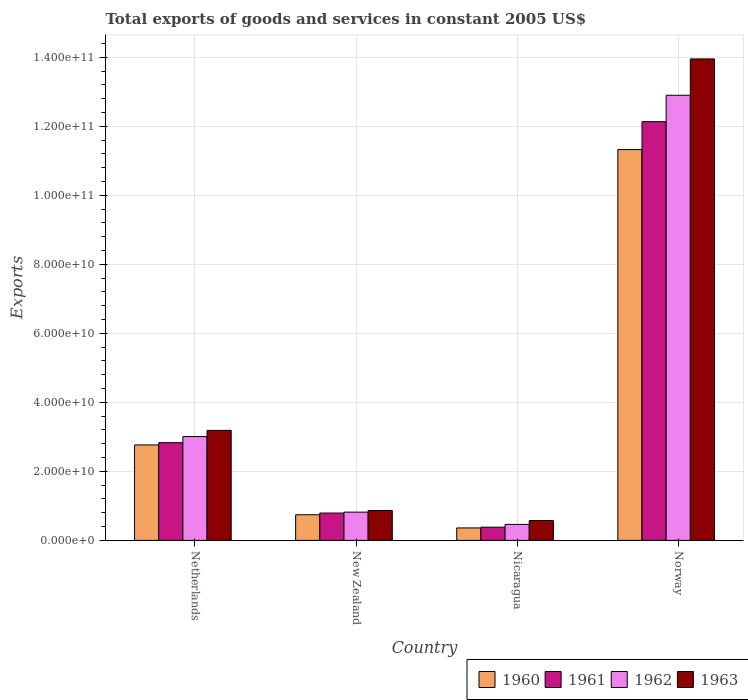How many different coloured bars are there?
Provide a succinct answer. 4. What is the label of the 2nd group of bars from the left?
Your answer should be very brief. New Zealand. In how many cases, is the number of bars for a given country not equal to the number of legend labels?
Ensure brevity in your answer.  0. What is the total exports of goods and services in 1961 in Netherlands?
Provide a succinct answer. 2.83e+1. Across all countries, what is the maximum total exports of goods and services in 1962?
Provide a succinct answer. 1.29e+11. Across all countries, what is the minimum total exports of goods and services in 1963?
Provide a short and direct response. 5.74e+09. In which country was the total exports of goods and services in 1961 minimum?
Offer a very short reply. Nicaragua. What is the total total exports of goods and services in 1961 in the graph?
Your answer should be very brief. 1.61e+11. What is the difference between the total exports of goods and services in 1962 in New Zealand and that in Nicaragua?
Give a very brief answer. 3.55e+09. What is the difference between the total exports of goods and services in 1961 in New Zealand and the total exports of goods and services in 1960 in Netherlands?
Your answer should be very brief. -1.97e+1. What is the average total exports of goods and services in 1963 per country?
Offer a terse response. 4.64e+1. What is the difference between the total exports of goods and services of/in 1960 and total exports of goods and services of/in 1961 in Nicaragua?
Give a very brief answer. -2.16e+08. What is the ratio of the total exports of goods and services in 1963 in Netherlands to that in Norway?
Your answer should be very brief. 0.23. Is the difference between the total exports of goods and services in 1960 in New Zealand and Nicaragua greater than the difference between the total exports of goods and services in 1961 in New Zealand and Nicaragua?
Ensure brevity in your answer.  No. What is the difference between the highest and the second highest total exports of goods and services in 1962?
Keep it short and to the point. 1.21e+11. What is the difference between the highest and the lowest total exports of goods and services in 1962?
Keep it short and to the point. 1.24e+11. Is it the case that in every country, the sum of the total exports of goods and services in 1962 and total exports of goods and services in 1960 is greater than the sum of total exports of goods and services in 1963 and total exports of goods and services in 1961?
Give a very brief answer. No. What does the 4th bar from the left in Nicaragua represents?
Offer a very short reply. 1963. How many countries are there in the graph?
Ensure brevity in your answer.  4. What is the difference between two consecutive major ticks on the Y-axis?
Offer a very short reply. 2.00e+1. Where does the legend appear in the graph?
Keep it short and to the point. Bottom right. How are the legend labels stacked?
Ensure brevity in your answer.  Horizontal. What is the title of the graph?
Your answer should be compact. Total exports of goods and services in constant 2005 US$. Does "1991" appear as one of the legend labels in the graph?
Make the answer very short. No. What is the label or title of the Y-axis?
Make the answer very short. Exports. What is the Exports of 1960 in Netherlands?
Provide a short and direct response. 2.77e+1. What is the Exports of 1961 in Netherlands?
Ensure brevity in your answer.  2.83e+1. What is the Exports of 1962 in Netherlands?
Provide a short and direct response. 3.01e+1. What is the Exports in 1963 in Netherlands?
Provide a succinct answer. 3.19e+1. What is the Exports in 1960 in New Zealand?
Ensure brevity in your answer.  7.43e+09. What is the Exports in 1961 in New Zealand?
Offer a very short reply. 7.92e+09. What is the Exports of 1962 in New Zealand?
Make the answer very short. 8.19e+09. What is the Exports of 1963 in New Zealand?
Your response must be concise. 8.66e+09. What is the Exports of 1960 in Nicaragua?
Provide a short and direct response. 3.61e+09. What is the Exports of 1961 in Nicaragua?
Ensure brevity in your answer.  3.83e+09. What is the Exports in 1962 in Nicaragua?
Keep it short and to the point. 4.64e+09. What is the Exports in 1963 in Nicaragua?
Your answer should be very brief. 5.74e+09. What is the Exports in 1960 in Norway?
Give a very brief answer. 1.13e+11. What is the Exports of 1961 in Norway?
Keep it short and to the point. 1.21e+11. What is the Exports in 1962 in Norway?
Your answer should be very brief. 1.29e+11. What is the Exports of 1963 in Norway?
Offer a terse response. 1.40e+11. Across all countries, what is the maximum Exports in 1960?
Offer a terse response. 1.13e+11. Across all countries, what is the maximum Exports of 1961?
Your answer should be compact. 1.21e+11. Across all countries, what is the maximum Exports of 1962?
Your answer should be very brief. 1.29e+11. Across all countries, what is the maximum Exports in 1963?
Your answer should be very brief. 1.40e+11. Across all countries, what is the minimum Exports in 1960?
Offer a very short reply. 3.61e+09. Across all countries, what is the minimum Exports of 1961?
Ensure brevity in your answer.  3.83e+09. Across all countries, what is the minimum Exports in 1962?
Keep it short and to the point. 4.64e+09. Across all countries, what is the minimum Exports in 1963?
Offer a very short reply. 5.74e+09. What is the total Exports in 1960 in the graph?
Your answer should be very brief. 1.52e+11. What is the total Exports in 1961 in the graph?
Your response must be concise. 1.61e+11. What is the total Exports in 1962 in the graph?
Your response must be concise. 1.72e+11. What is the total Exports in 1963 in the graph?
Keep it short and to the point. 1.86e+11. What is the difference between the Exports of 1960 in Netherlands and that in New Zealand?
Your response must be concise. 2.02e+1. What is the difference between the Exports of 1961 in Netherlands and that in New Zealand?
Ensure brevity in your answer.  2.04e+1. What is the difference between the Exports of 1962 in Netherlands and that in New Zealand?
Your answer should be very brief. 2.19e+1. What is the difference between the Exports of 1963 in Netherlands and that in New Zealand?
Offer a very short reply. 2.32e+1. What is the difference between the Exports in 1960 in Netherlands and that in Nicaragua?
Provide a short and direct response. 2.41e+1. What is the difference between the Exports in 1961 in Netherlands and that in Nicaragua?
Provide a succinct answer. 2.45e+1. What is the difference between the Exports of 1962 in Netherlands and that in Nicaragua?
Your answer should be very brief. 2.54e+1. What is the difference between the Exports of 1963 in Netherlands and that in Nicaragua?
Keep it short and to the point. 2.61e+1. What is the difference between the Exports in 1960 in Netherlands and that in Norway?
Ensure brevity in your answer.  -8.56e+1. What is the difference between the Exports of 1961 in Netherlands and that in Norway?
Your answer should be very brief. -9.30e+1. What is the difference between the Exports of 1962 in Netherlands and that in Norway?
Make the answer very short. -9.89e+1. What is the difference between the Exports of 1963 in Netherlands and that in Norway?
Your response must be concise. -1.08e+11. What is the difference between the Exports of 1960 in New Zealand and that in Nicaragua?
Make the answer very short. 3.82e+09. What is the difference between the Exports of 1961 in New Zealand and that in Nicaragua?
Offer a very short reply. 4.10e+09. What is the difference between the Exports in 1962 in New Zealand and that in Nicaragua?
Offer a terse response. 3.55e+09. What is the difference between the Exports of 1963 in New Zealand and that in Nicaragua?
Keep it short and to the point. 2.92e+09. What is the difference between the Exports in 1960 in New Zealand and that in Norway?
Your answer should be compact. -1.06e+11. What is the difference between the Exports of 1961 in New Zealand and that in Norway?
Give a very brief answer. -1.13e+11. What is the difference between the Exports in 1962 in New Zealand and that in Norway?
Offer a terse response. -1.21e+11. What is the difference between the Exports in 1963 in New Zealand and that in Norway?
Give a very brief answer. -1.31e+11. What is the difference between the Exports of 1960 in Nicaragua and that in Norway?
Your response must be concise. -1.10e+11. What is the difference between the Exports in 1961 in Nicaragua and that in Norway?
Keep it short and to the point. -1.18e+11. What is the difference between the Exports of 1962 in Nicaragua and that in Norway?
Offer a very short reply. -1.24e+11. What is the difference between the Exports in 1963 in Nicaragua and that in Norway?
Keep it short and to the point. -1.34e+11. What is the difference between the Exports in 1960 in Netherlands and the Exports in 1961 in New Zealand?
Give a very brief answer. 1.97e+1. What is the difference between the Exports of 1960 in Netherlands and the Exports of 1962 in New Zealand?
Ensure brevity in your answer.  1.95e+1. What is the difference between the Exports of 1960 in Netherlands and the Exports of 1963 in New Zealand?
Provide a succinct answer. 1.90e+1. What is the difference between the Exports in 1961 in Netherlands and the Exports in 1962 in New Zealand?
Your answer should be compact. 2.01e+1. What is the difference between the Exports in 1961 in Netherlands and the Exports in 1963 in New Zealand?
Ensure brevity in your answer.  1.97e+1. What is the difference between the Exports in 1962 in Netherlands and the Exports in 1963 in New Zealand?
Your answer should be compact. 2.14e+1. What is the difference between the Exports in 1960 in Netherlands and the Exports in 1961 in Nicaragua?
Provide a succinct answer. 2.38e+1. What is the difference between the Exports of 1960 in Netherlands and the Exports of 1962 in Nicaragua?
Offer a terse response. 2.30e+1. What is the difference between the Exports of 1960 in Netherlands and the Exports of 1963 in Nicaragua?
Ensure brevity in your answer.  2.19e+1. What is the difference between the Exports in 1961 in Netherlands and the Exports in 1962 in Nicaragua?
Your answer should be compact. 2.37e+1. What is the difference between the Exports of 1961 in Netherlands and the Exports of 1963 in Nicaragua?
Keep it short and to the point. 2.26e+1. What is the difference between the Exports in 1962 in Netherlands and the Exports in 1963 in Nicaragua?
Make the answer very short. 2.43e+1. What is the difference between the Exports in 1960 in Netherlands and the Exports in 1961 in Norway?
Provide a succinct answer. -9.37e+1. What is the difference between the Exports in 1960 in Netherlands and the Exports in 1962 in Norway?
Offer a terse response. -1.01e+11. What is the difference between the Exports of 1960 in Netherlands and the Exports of 1963 in Norway?
Your response must be concise. -1.12e+11. What is the difference between the Exports of 1961 in Netherlands and the Exports of 1962 in Norway?
Provide a succinct answer. -1.01e+11. What is the difference between the Exports of 1961 in Netherlands and the Exports of 1963 in Norway?
Ensure brevity in your answer.  -1.11e+11. What is the difference between the Exports of 1962 in Netherlands and the Exports of 1963 in Norway?
Your answer should be very brief. -1.09e+11. What is the difference between the Exports in 1960 in New Zealand and the Exports in 1961 in Nicaragua?
Keep it short and to the point. 3.60e+09. What is the difference between the Exports of 1960 in New Zealand and the Exports of 1962 in Nicaragua?
Give a very brief answer. 2.79e+09. What is the difference between the Exports in 1960 in New Zealand and the Exports in 1963 in Nicaragua?
Offer a terse response. 1.68e+09. What is the difference between the Exports in 1961 in New Zealand and the Exports in 1962 in Nicaragua?
Make the answer very short. 3.29e+09. What is the difference between the Exports in 1961 in New Zealand and the Exports in 1963 in Nicaragua?
Your response must be concise. 2.18e+09. What is the difference between the Exports of 1962 in New Zealand and the Exports of 1963 in Nicaragua?
Offer a terse response. 2.45e+09. What is the difference between the Exports in 1960 in New Zealand and the Exports in 1961 in Norway?
Your answer should be very brief. -1.14e+11. What is the difference between the Exports in 1960 in New Zealand and the Exports in 1962 in Norway?
Ensure brevity in your answer.  -1.22e+11. What is the difference between the Exports of 1960 in New Zealand and the Exports of 1963 in Norway?
Provide a succinct answer. -1.32e+11. What is the difference between the Exports in 1961 in New Zealand and the Exports in 1962 in Norway?
Offer a terse response. -1.21e+11. What is the difference between the Exports in 1961 in New Zealand and the Exports in 1963 in Norway?
Give a very brief answer. -1.32e+11. What is the difference between the Exports of 1962 in New Zealand and the Exports of 1963 in Norway?
Keep it short and to the point. -1.31e+11. What is the difference between the Exports of 1960 in Nicaragua and the Exports of 1961 in Norway?
Ensure brevity in your answer.  -1.18e+11. What is the difference between the Exports in 1960 in Nicaragua and the Exports in 1962 in Norway?
Your answer should be compact. -1.25e+11. What is the difference between the Exports in 1960 in Nicaragua and the Exports in 1963 in Norway?
Give a very brief answer. -1.36e+11. What is the difference between the Exports in 1961 in Nicaragua and the Exports in 1962 in Norway?
Make the answer very short. -1.25e+11. What is the difference between the Exports of 1961 in Nicaragua and the Exports of 1963 in Norway?
Provide a succinct answer. -1.36e+11. What is the difference between the Exports of 1962 in Nicaragua and the Exports of 1963 in Norway?
Ensure brevity in your answer.  -1.35e+11. What is the average Exports of 1960 per country?
Ensure brevity in your answer.  3.80e+1. What is the average Exports in 1961 per country?
Ensure brevity in your answer.  4.03e+1. What is the average Exports in 1962 per country?
Provide a succinct answer. 4.30e+1. What is the average Exports in 1963 per country?
Give a very brief answer. 4.64e+1. What is the difference between the Exports of 1960 and Exports of 1961 in Netherlands?
Keep it short and to the point. -6.49e+08. What is the difference between the Exports in 1960 and Exports in 1962 in Netherlands?
Ensure brevity in your answer.  -2.42e+09. What is the difference between the Exports of 1960 and Exports of 1963 in Netherlands?
Your response must be concise. -4.21e+09. What is the difference between the Exports of 1961 and Exports of 1962 in Netherlands?
Your response must be concise. -1.77e+09. What is the difference between the Exports in 1961 and Exports in 1963 in Netherlands?
Keep it short and to the point. -3.57e+09. What is the difference between the Exports of 1962 and Exports of 1963 in Netherlands?
Give a very brief answer. -1.80e+09. What is the difference between the Exports of 1960 and Exports of 1961 in New Zealand?
Provide a succinct answer. -4.96e+08. What is the difference between the Exports of 1960 and Exports of 1962 in New Zealand?
Ensure brevity in your answer.  -7.63e+08. What is the difference between the Exports of 1960 and Exports of 1963 in New Zealand?
Ensure brevity in your answer.  -1.23e+09. What is the difference between the Exports in 1961 and Exports in 1962 in New Zealand?
Offer a very short reply. -2.67e+08. What is the difference between the Exports of 1961 and Exports of 1963 in New Zealand?
Provide a short and direct response. -7.36e+08. What is the difference between the Exports of 1962 and Exports of 1963 in New Zealand?
Your answer should be compact. -4.69e+08. What is the difference between the Exports of 1960 and Exports of 1961 in Nicaragua?
Provide a succinct answer. -2.16e+08. What is the difference between the Exports of 1960 and Exports of 1962 in Nicaragua?
Make the answer very short. -1.02e+09. What is the difference between the Exports of 1960 and Exports of 1963 in Nicaragua?
Provide a succinct answer. -2.13e+09. What is the difference between the Exports of 1961 and Exports of 1962 in Nicaragua?
Provide a short and direct response. -8.09e+08. What is the difference between the Exports of 1961 and Exports of 1963 in Nicaragua?
Make the answer very short. -1.92e+09. What is the difference between the Exports of 1962 and Exports of 1963 in Nicaragua?
Keep it short and to the point. -1.11e+09. What is the difference between the Exports of 1960 and Exports of 1961 in Norway?
Give a very brief answer. -8.08e+09. What is the difference between the Exports of 1960 and Exports of 1962 in Norway?
Your answer should be compact. -1.57e+1. What is the difference between the Exports of 1960 and Exports of 1963 in Norway?
Your response must be concise. -2.63e+1. What is the difference between the Exports of 1961 and Exports of 1962 in Norway?
Provide a succinct answer. -7.65e+09. What is the difference between the Exports in 1961 and Exports in 1963 in Norway?
Provide a succinct answer. -1.82e+1. What is the difference between the Exports in 1962 and Exports in 1963 in Norway?
Your answer should be compact. -1.05e+1. What is the ratio of the Exports in 1960 in Netherlands to that in New Zealand?
Offer a terse response. 3.72. What is the ratio of the Exports of 1961 in Netherlands to that in New Zealand?
Give a very brief answer. 3.57. What is the ratio of the Exports in 1962 in Netherlands to that in New Zealand?
Your answer should be very brief. 3.67. What is the ratio of the Exports in 1963 in Netherlands to that in New Zealand?
Offer a terse response. 3.68. What is the ratio of the Exports in 1960 in Netherlands to that in Nicaragua?
Your answer should be very brief. 7.66. What is the ratio of the Exports in 1961 in Netherlands to that in Nicaragua?
Ensure brevity in your answer.  7.4. What is the ratio of the Exports of 1962 in Netherlands to that in Nicaragua?
Make the answer very short. 6.49. What is the ratio of the Exports of 1963 in Netherlands to that in Nicaragua?
Your answer should be compact. 5.55. What is the ratio of the Exports of 1960 in Netherlands to that in Norway?
Make the answer very short. 0.24. What is the ratio of the Exports in 1961 in Netherlands to that in Norway?
Offer a terse response. 0.23. What is the ratio of the Exports in 1962 in Netherlands to that in Norway?
Your response must be concise. 0.23. What is the ratio of the Exports of 1963 in Netherlands to that in Norway?
Ensure brevity in your answer.  0.23. What is the ratio of the Exports of 1960 in New Zealand to that in Nicaragua?
Ensure brevity in your answer.  2.06. What is the ratio of the Exports in 1961 in New Zealand to that in Nicaragua?
Your answer should be very brief. 2.07. What is the ratio of the Exports of 1962 in New Zealand to that in Nicaragua?
Your answer should be compact. 1.77. What is the ratio of the Exports in 1963 in New Zealand to that in Nicaragua?
Offer a very short reply. 1.51. What is the ratio of the Exports in 1960 in New Zealand to that in Norway?
Your response must be concise. 0.07. What is the ratio of the Exports of 1961 in New Zealand to that in Norway?
Give a very brief answer. 0.07. What is the ratio of the Exports of 1962 in New Zealand to that in Norway?
Provide a succinct answer. 0.06. What is the ratio of the Exports of 1963 in New Zealand to that in Norway?
Offer a terse response. 0.06. What is the ratio of the Exports in 1960 in Nicaragua to that in Norway?
Give a very brief answer. 0.03. What is the ratio of the Exports of 1961 in Nicaragua to that in Norway?
Your response must be concise. 0.03. What is the ratio of the Exports in 1962 in Nicaragua to that in Norway?
Provide a succinct answer. 0.04. What is the ratio of the Exports in 1963 in Nicaragua to that in Norway?
Ensure brevity in your answer.  0.04. What is the difference between the highest and the second highest Exports in 1960?
Offer a terse response. 8.56e+1. What is the difference between the highest and the second highest Exports of 1961?
Offer a very short reply. 9.30e+1. What is the difference between the highest and the second highest Exports of 1962?
Your answer should be very brief. 9.89e+1. What is the difference between the highest and the second highest Exports in 1963?
Give a very brief answer. 1.08e+11. What is the difference between the highest and the lowest Exports of 1960?
Your response must be concise. 1.10e+11. What is the difference between the highest and the lowest Exports in 1961?
Offer a very short reply. 1.18e+11. What is the difference between the highest and the lowest Exports in 1962?
Provide a short and direct response. 1.24e+11. What is the difference between the highest and the lowest Exports in 1963?
Keep it short and to the point. 1.34e+11. 